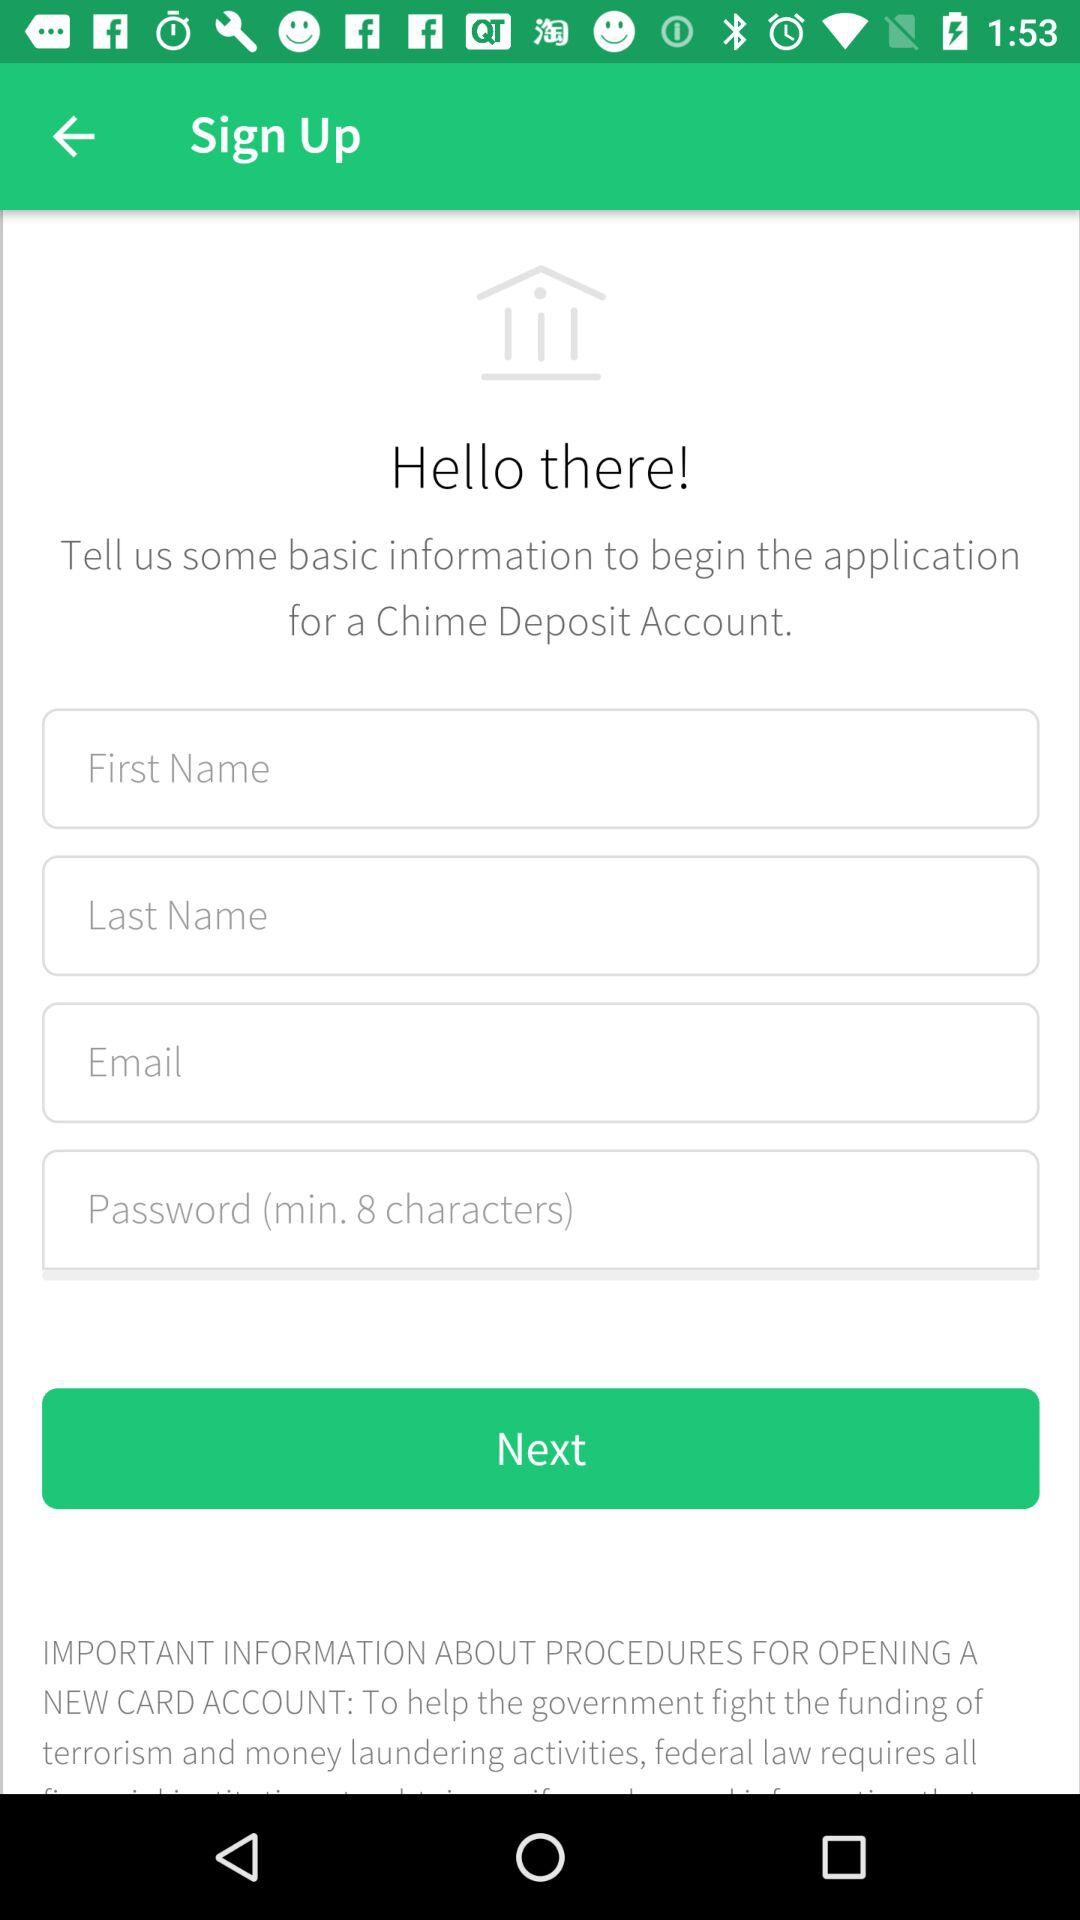How many text inputs are required to open a Chime Deposit Account?
Answer the question using a single word or phrase. 4 